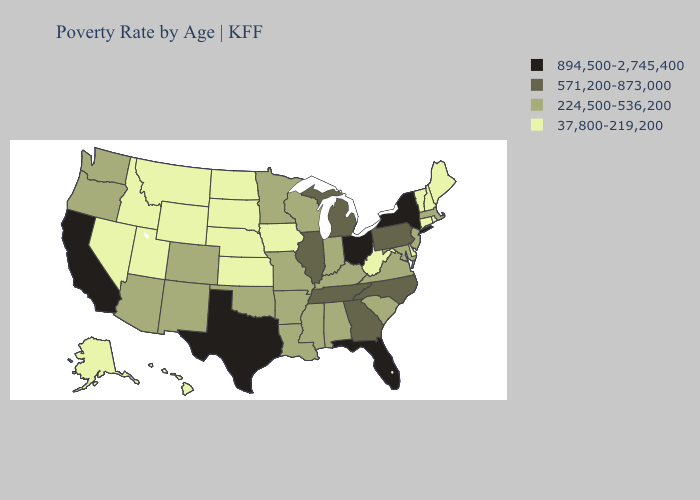What is the lowest value in states that border Minnesota?
Be succinct. 37,800-219,200. Name the states that have a value in the range 571,200-873,000?
Give a very brief answer. Georgia, Illinois, Michigan, North Carolina, Pennsylvania, Tennessee. Does Tennessee have the same value as Florida?
Keep it brief. No. What is the highest value in states that border Rhode Island?
Keep it brief. 224,500-536,200. Name the states that have a value in the range 224,500-536,200?
Answer briefly. Alabama, Arizona, Arkansas, Colorado, Indiana, Kentucky, Louisiana, Maryland, Massachusetts, Minnesota, Mississippi, Missouri, New Jersey, New Mexico, Oklahoma, Oregon, South Carolina, Virginia, Washington, Wisconsin. What is the value of Connecticut?
Write a very short answer. 37,800-219,200. What is the highest value in the Northeast ?
Quick response, please. 894,500-2,745,400. Name the states that have a value in the range 37,800-219,200?
Give a very brief answer. Alaska, Connecticut, Delaware, Hawaii, Idaho, Iowa, Kansas, Maine, Montana, Nebraska, Nevada, New Hampshire, North Dakota, Rhode Island, South Dakota, Utah, Vermont, West Virginia, Wyoming. What is the value of Missouri?
Keep it brief. 224,500-536,200. Does the map have missing data?
Concise answer only. No. What is the highest value in the South ?
Short answer required. 894,500-2,745,400. What is the highest value in the USA?
Quick response, please. 894,500-2,745,400. What is the lowest value in states that border Mississippi?
Keep it brief. 224,500-536,200. Does the map have missing data?
Answer briefly. No. Among the states that border Alabama , does Florida have the highest value?
Answer briefly. Yes. 